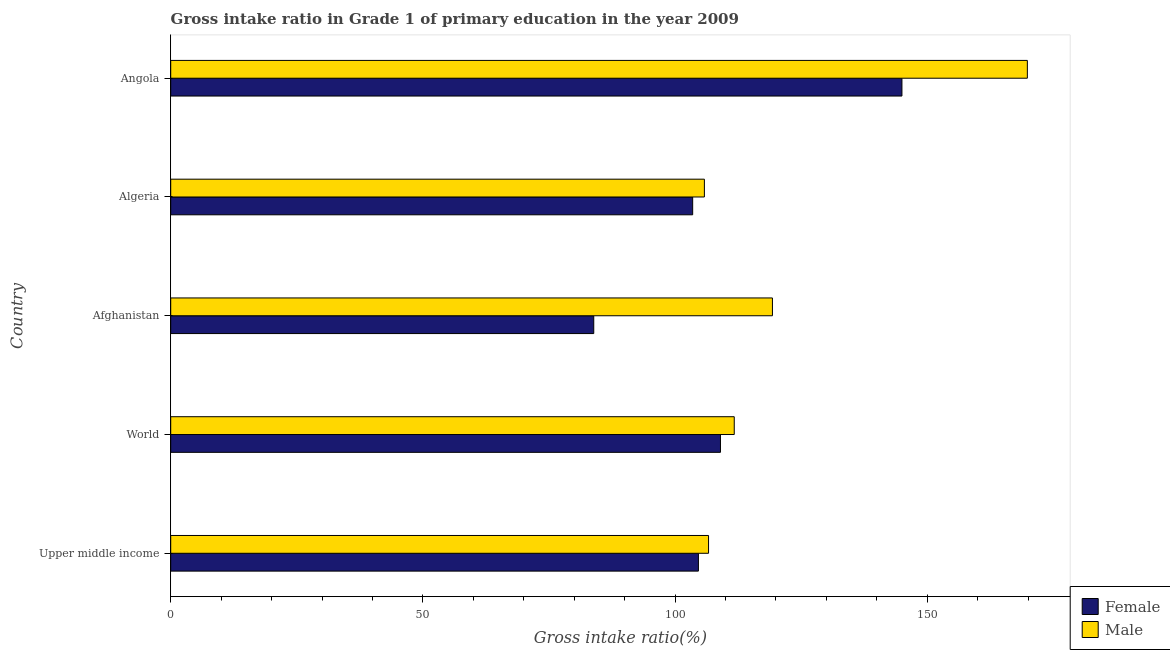How many different coloured bars are there?
Ensure brevity in your answer.  2. How many groups of bars are there?
Your answer should be very brief. 5. How many bars are there on the 1st tick from the top?
Offer a very short reply. 2. What is the label of the 1st group of bars from the top?
Ensure brevity in your answer.  Angola. In how many cases, is the number of bars for a given country not equal to the number of legend labels?
Offer a terse response. 0. What is the gross intake ratio(female) in Upper middle income?
Provide a short and direct response. 104.64. Across all countries, what is the maximum gross intake ratio(male)?
Give a very brief answer. 169.86. Across all countries, what is the minimum gross intake ratio(male)?
Keep it short and to the point. 105.82. In which country was the gross intake ratio(female) maximum?
Keep it short and to the point. Angola. In which country was the gross intake ratio(female) minimum?
Make the answer very short. Afghanistan. What is the total gross intake ratio(female) in the graph?
Give a very brief answer. 546.02. What is the difference between the gross intake ratio(male) in Afghanistan and that in Upper middle income?
Offer a very short reply. 12.67. What is the difference between the gross intake ratio(female) in World and the gross intake ratio(male) in Algeria?
Keep it short and to the point. 3.19. What is the average gross intake ratio(female) per country?
Give a very brief answer. 109.2. What is the difference between the gross intake ratio(female) and gross intake ratio(male) in World?
Your answer should be very brief. -2.73. What is the ratio of the gross intake ratio(male) in Angola to that in Upper middle income?
Your answer should be compact. 1.59. What is the difference between the highest and the second highest gross intake ratio(female)?
Ensure brevity in your answer.  35.99. What is the difference between the highest and the lowest gross intake ratio(male)?
Make the answer very short. 64.04. Is the sum of the gross intake ratio(female) in Algeria and Upper middle income greater than the maximum gross intake ratio(male) across all countries?
Your response must be concise. Yes. What does the 1st bar from the top in World represents?
Offer a very short reply. Male. What does the 1st bar from the bottom in Angola represents?
Offer a very short reply. Female. Are all the bars in the graph horizontal?
Your answer should be compact. Yes. How many countries are there in the graph?
Make the answer very short. 5. Are the values on the major ticks of X-axis written in scientific E-notation?
Provide a short and direct response. No. Does the graph contain any zero values?
Offer a very short reply. No. Does the graph contain grids?
Your response must be concise. No. How many legend labels are there?
Offer a very short reply. 2. What is the title of the graph?
Ensure brevity in your answer.  Gross intake ratio in Grade 1 of primary education in the year 2009. What is the label or title of the X-axis?
Ensure brevity in your answer.  Gross intake ratio(%). What is the label or title of the Y-axis?
Your answer should be very brief. Country. What is the Gross intake ratio(%) of Female in Upper middle income?
Offer a terse response. 104.64. What is the Gross intake ratio(%) of Male in Upper middle income?
Ensure brevity in your answer.  106.64. What is the Gross intake ratio(%) in Female in World?
Give a very brief answer. 109.01. What is the Gross intake ratio(%) of Male in World?
Your answer should be very brief. 111.74. What is the Gross intake ratio(%) of Female in Afghanistan?
Your answer should be compact. 83.88. What is the Gross intake ratio(%) in Male in Afghanistan?
Ensure brevity in your answer.  119.31. What is the Gross intake ratio(%) of Female in Algeria?
Your answer should be compact. 103.5. What is the Gross intake ratio(%) of Male in Algeria?
Your response must be concise. 105.82. What is the Gross intake ratio(%) in Female in Angola?
Your response must be concise. 144.99. What is the Gross intake ratio(%) in Male in Angola?
Your answer should be compact. 169.86. Across all countries, what is the maximum Gross intake ratio(%) of Female?
Keep it short and to the point. 144.99. Across all countries, what is the maximum Gross intake ratio(%) in Male?
Make the answer very short. 169.86. Across all countries, what is the minimum Gross intake ratio(%) in Female?
Your answer should be very brief. 83.88. Across all countries, what is the minimum Gross intake ratio(%) in Male?
Give a very brief answer. 105.82. What is the total Gross intake ratio(%) in Female in the graph?
Keep it short and to the point. 546.02. What is the total Gross intake ratio(%) of Male in the graph?
Ensure brevity in your answer.  613.38. What is the difference between the Gross intake ratio(%) of Female in Upper middle income and that in World?
Your answer should be very brief. -4.37. What is the difference between the Gross intake ratio(%) in Male in Upper middle income and that in World?
Your answer should be very brief. -5.1. What is the difference between the Gross intake ratio(%) in Female in Upper middle income and that in Afghanistan?
Offer a very short reply. 20.75. What is the difference between the Gross intake ratio(%) in Male in Upper middle income and that in Afghanistan?
Offer a very short reply. -12.67. What is the difference between the Gross intake ratio(%) in Female in Upper middle income and that in Algeria?
Keep it short and to the point. 1.14. What is the difference between the Gross intake ratio(%) in Male in Upper middle income and that in Algeria?
Your answer should be very brief. 0.82. What is the difference between the Gross intake ratio(%) in Female in Upper middle income and that in Angola?
Offer a terse response. -40.36. What is the difference between the Gross intake ratio(%) of Male in Upper middle income and that in Angola?
Make the answer very short. -63.22. What is the difference between the Gross intake ratio(%) in Female in World and that in Afghanistan?
Ensure brevity in your answer.  25.12. What is the difference between the Gross intake ratio(%) in Male in World and that in Afghanistan?
Offer a terse response. -7.57. What is the difference between the Gross intake ratio(%) in Female in World and that in Algeria?
Your answer should be compact. 5.51. What is the difference between the Gross intake ratio(%) in Male in World and that in Algeria?
Keep it short and to the point. 5.92. What is the difference between the Gross intake ratio(%) of Female in World and that in Angola?
Provide a succinct answer. -35.99. What is the difference between the Gross intake ratio(%) in Male in World and that in Angola?
Provide a succinct answer. -58.12. What is the difference between the Gross intake ratio(%) in Female in Afghanistan and that in Algeria?
Ensure brevity in your answer.  -19.62. What is the difference between the Gross intake ratio(%) in Male in Afghanistan and that in Algeria?
Your answer should be compact. 13.49. What is the difference between the Gross intake ratio(%) of Female in Afghanistan and that in Angola?
Your answer should be very brief. -61.11. What is the difference between the Gross intake ratio(%) in Male in Afghanistan and that in Angola?
Offer a terse response. -50.55. What is the difference between the Gross intake ratio(%) in Female in Algeria and that in Angola?
Give a very brief answer. -41.5. What is the difference between the Gross intake ratio(%) in Male in Algeria and that in Angola?
Offer a very short reply. -64.04. What is the difference between the Gross intake ratio(%) in Female in Upper middle income and the Gross intake ratio(%) in Male in World?
Provide a succinct answer. -7.11. What is the difference between the Gross intake ratio(%) of Female in Upper middle income and the Gross intake ratio(%) of Male in Afghanistan?
Ensure brevity in your answer.  -14.68. What is the difference between the Gross intake ratio(%) of Female in Upper middle income and the Gross intake ratio(%) of Male in Algeria?
Your answer should be compact. -1.18. What is the difference between the Gross intake ratio(%) of Female in Upper middle income and the Gross intake ratio(%) of Male in Angola?
Offer a very short reply. -65.23. What is the difference between the Gross intake ratio(%) in Female in World and the Gross intake ratio(%) in Male in Afghanistan?
Provide a short and direct response. -10.31. What is the difference between the Gross intake ratio(%) of Female in World and the Gross intake ratio(%) of Male in Algeria?
Provide a short and direct response. 3.19. What is the difference between the Gross intake ratio(%) in Female in World and the Gross intake ratio(%) in Male in Angola?
Provide a short and direct response. -60.85. What is the difference between the Gross intake ratio(%) in Female in Afghanistan and the Gross intake ratio(%) in Male in Algeria?
Keep it short and to the point. -21.94. What is the difference between the Gross intake ratio(%) in Female in Afghanistan and the Gross intake ratio(%) in Male in Angola?
Give a very brief answer. -85.98. What is the difference between the Gross intake ratio(%) in Female in Algeria and the Gross intake ratio(%) in Male in Angola?
Provide a succinct answer. -66.36. What is the average Gross intake ratio(%) of Female per country?
Offer a very short reply. 109.2. What is the average Gross intake ratio(%) in Male per country?
Your answer should be compact. 122.68. What is the difference between the Gross intake ratio(%) of Female and Gross intake ratio(%) of Male in Upper middle income?
Offer a terse response. -2.01. What is the difference between the Gross intake ratio(%) in Female and Gross intake ratio(%) in Male in World?
Keep it short and to the point. -2.73. What is the difference between the Gross intake ratio(%) of Female and Gross intake ratio(%) of Male in Afghanistan?
Ensure brevity in your answer.  -35.43. What is the difference between the Gross intake ratio(%) of Female and Gross intake ratio(%) of Male in Algeria?
Provide a short and direct response. -2.32. What is the difference between the Gross intake ratio(%) of Female and Gross intake ratio(%) of Male in Angola?
Make the answer very short. -24.87. What is the ratio of the Gross intake ratio(%) in Female in Upper middle income to that in World?
Your response must be concise. 0.96. What is the ratio of the Gross intake ratio(%) of Male in Upper middle income to that in World?
Your response must be concise. 0.95. What is the ratio of the Gross intake ratio(%) of Female in Upper middle income to that in Afghanistan?
Your answer should be very brief. 1.25. What is the ratio of the Gross intake ratio(%) in Male in Upper middle income to that in Afghanistan?
Keep it short and to the point. 0.89. What is the ratio of the Gross intake ratio(%) of Female in Upper middle income to that in Angola?
Keep it short and to the point. 0.72. What is the ratio of the Gross intake ratio(%) of Male in Upper middle income to that in Angola?
Your answer should be compact. 0.63. What is the ratio of the Gross intake ratio(%) of Female in World to that in Afghanistan?
Provide a succinct answer. 1.3. What is the ratio of the Gross intake ratio(%) in Male in World to that in Afghanistan?
Keep it short and to the point. 0.94. What is the ratio of the Gross intake ratio(%) of Female in World to that in Algeria?
Your answer should be compact. 1.05. What is the ratio of the Gross intake ratio(%) of Male in World to that in Algeria?
Your answer should be very brief. 1.06. What is the ratio of the Gross intake ratio(%) of Female in World to that in Angola?
Your answer should be very brief. 0.75. What is the ratio of the Gross intake ratio(%) in Male in World to that in Angola?
Make the answer very short. 0.66. What is the ratio of the Gross intake ratio(%) in Female in Afghanistan to that in Algeria?
Your answer should be very brief. 0.81. What is the ratio of the Gross intake ratio(%) in Male in Afghanistan to that in Algeria?
Your answer should be very brief. 1.13. What is the ratio of the Gross intake ratio(%) in Female in Afghanistan to that in Angola?
Ensure brevity in your answer.  0.58. What is the ratio of the Gross intake ratio(%) of Male in Afghanistan to that in Angola?
Keep it short and to the point. 0.7. What is the ratio of the Gross intake ratio(%) of Female in Algeria to that in Angola?
Ensure brevity in your answer.  0.71. What is the ratio of the Gross intake ratio(%) in Male in Algeria to that in Angola?
Your response must be concise. 0.62. What is the difference between the highest and the second highest Gross intake ratio(%) in Female?
Provide a short and direct response. 35.99. What is the difference between the highest and the second highest Gross intake ratio(%) in Male?
Provide a short and direct response. 50.55. What is the difference between the highest and the lowest Gross intake ratio(%) of Female?
Keep it short and to the point. 61.11. What is the difference between the highest and the lowest Gross intake ratio(%) in Male?
Offer a terse response. 64.04. 